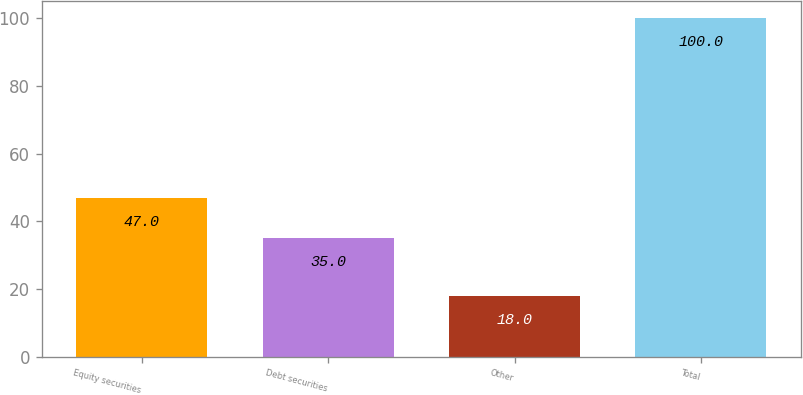Convert chart to OTSL. <chart><loc_0><loc_0><loc_500><loc_500><bar_chart><fcel>Equity securities<fcel>Debt securities<fcel>Other<fcel>Total<nl><fcel>47<fcel>35<fcel>18<fcel>100<nl></chart> 